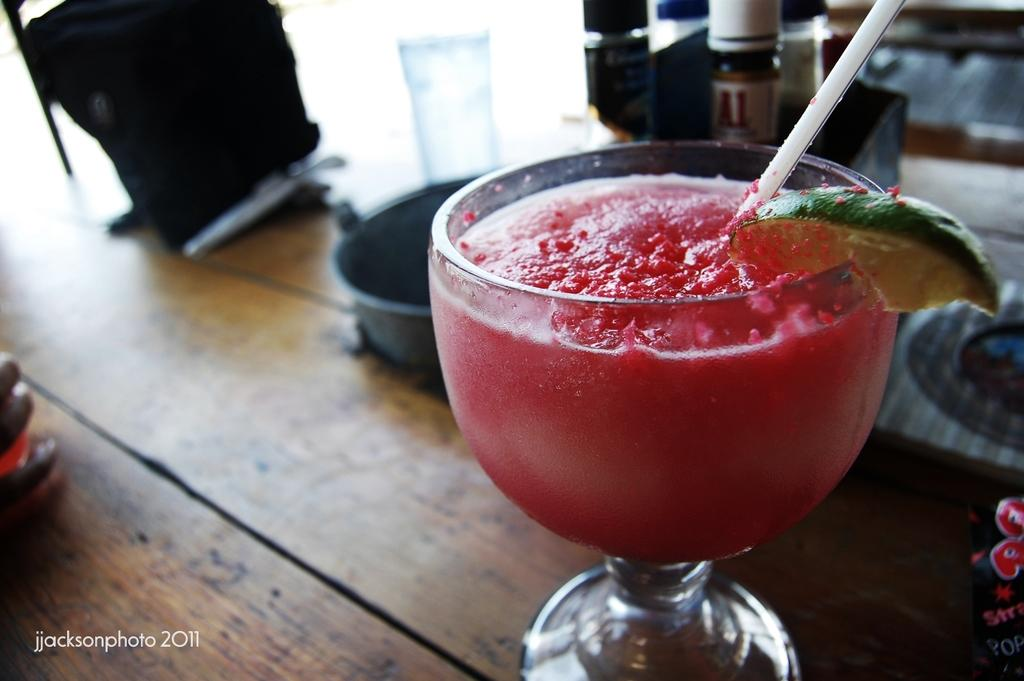What type of furniture is present in the image? There is a table in the image. What is in the glass that is visible in the image? There is juice and a straw in the glass. What other vessel can be seen in the image? There is a vessel in the image. Are there any other glasses present in the image? Yes, there is another glass in the image. What else can be seen in the image that might contain a liquid? There is a bottle in the image. Can you see any quicksand in the image? No, there is no quicksand present in the image. What type of vehicle is parked near the table in the image? There is no vehicle, such as a van, present in the image. 